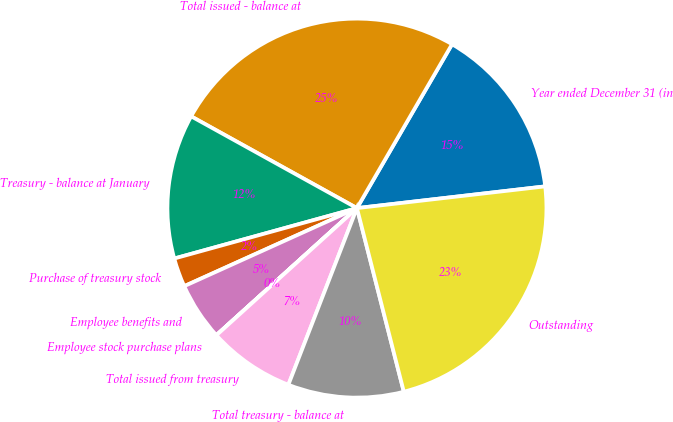Convert chart to OTSL. <chart><loc_0><loc_0><loc_500><loc_500><pie_chart><fcel>Year ended December 31 (in<fcel>Total issued - balance at<fcel>Treasury - balance at January<fcel>Purchase of treasury stock<fcel>Employee benefits and<fcel>Employee stock purchase plans<fcel>Total issued from treasury<fcel>Total treasury - balance at<fcel>Outstanding<nl><fcel>14.8%<fcel>25.32%<fcel>12.33%<fcel>2.47%<fcel>4.94%<fcel>0.01%<fcel>7.4%<fcel>9.87%<fcel>22.85%<nl></chart> 